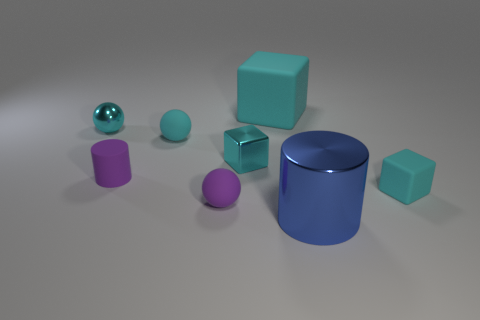How many cyan cubes must be subtracted to get 1 cyan cubes? 2 Subtract 1 blocks. How many blocks are left? 2 Add 2 big cylinders. How many objects exist? 10 Subtract all cylinders. How many objects are left? 6 Subtract 0 blue cubes. How many objects are left? 8 Subtract all large blue cylinders. Subtract all large blue shiny cylinders. How many objects are left? 6 Add 4 tiny rubber cylinders. How many tiny rubber cylinders are left? 5 Add 4 small metal balls. How many small metal balls exist? 5 